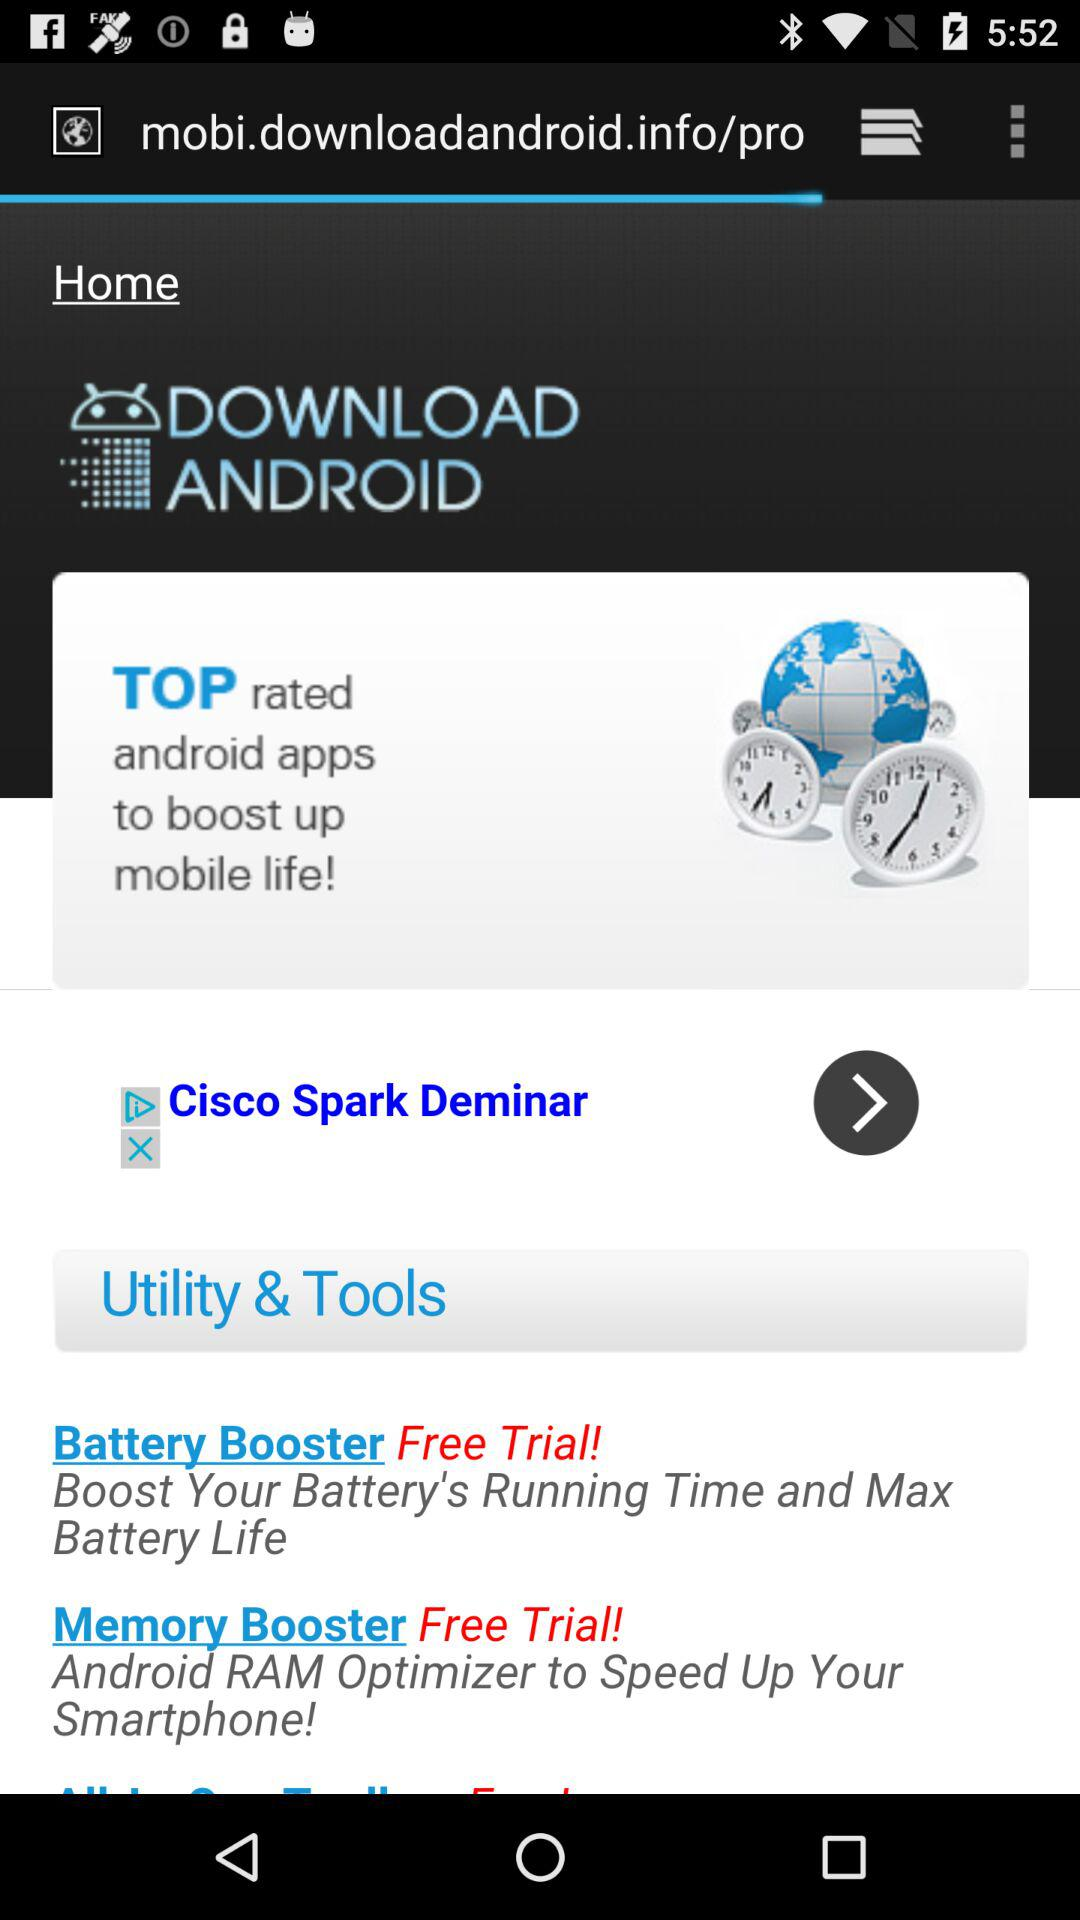What's the trial cost of "Battery Booster"? The trial of "Battery Booster" is free. 